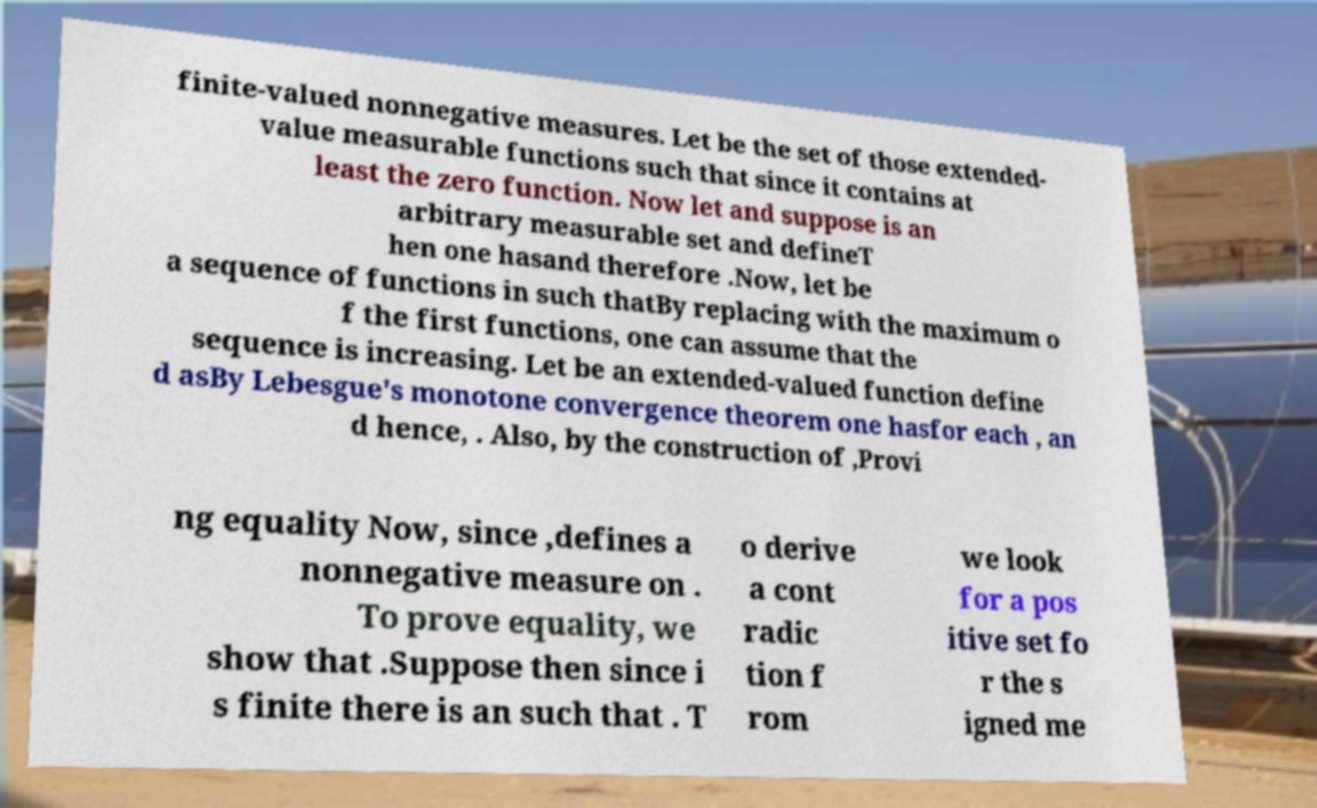Can you accurately transcribe the text from the provided image for me? finite-valued nonnegative measures. Let be the set of those extended- value measurable functions such that since it contains at least the zero function. Now let and suppose is an arbitrary measurable set and defineT hen one hasand therefore .Now, let be a sequence of functions in such thatBy replacing with the maximum o f the first functions, one can assume that the sequence is increasing. Let be an extended-valued function define d asBy Lebesgue's monotone convergence theorem one hasfor each , an d hence, . Also, by the construction of ,Provi ng equality Now, since ,defines a nonnegative measure on . To prove equality, we show that .Suppose then since i s finite there is an such that . T o derive a cont radic tion f rom we look for a pos itive set fo r the s igned me 